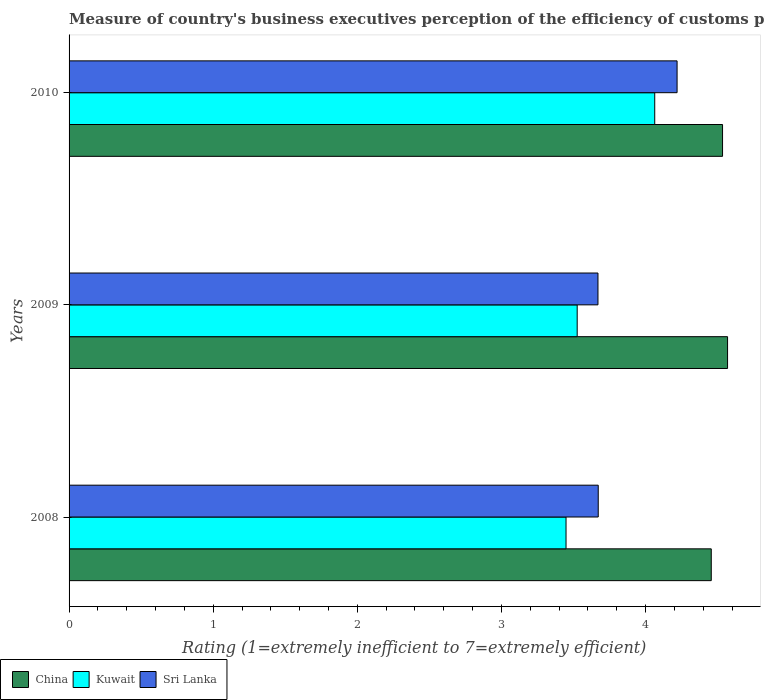How many different coloured bars are there?
Offer a terse response. 3. Are the number of bars on each tick of the Y-axis equal?
Keep it short and to the point. Yes. How many bars are there on the 1st tick from the top?
Offer a very short reply. 3. How many bars are there on the 2nd tick from the bottom?
Give a very brief answer. 3. What is the label of the 1st group of bars from the top?
Keep it short and to the point. 2010. In how many cases, is the number of bars for a given year not equal to the number of legend labels?
Keep it short and to the point. 0. What is the rating of the efficiency of customs procedure in Kuwait in 2009?
Offer a very short reply. 3.53. Across all years, what is the maximum rating of the efficiency of customs procedure in Kuwait?
Ensure brevity in your answer.  4.06. Across all years, what is the minimum rating of the efficiency of customs procedure in China?
Make the answer very short. 4.46. In which year was the rating of the efficiency of customs procedure in Kuwait maximum?
Give a very brief answer. 2010. In which year was the rating of the efficiency of customs procedure in China minimum?
Offer a terse response. 2008. What is the total rating of the efficiency of customs procedure in Kuwait in the graph?
Provide a short and direct response. 11.04. What is the difference between the rating of the efficiency of customs procedure in Sri Lanka in 2008 and that in 2010?
Provide a succinct answer. -0.55. What is the difference between the rating of the efficiency of customs procedure in Sri Lanka in 2010 and the rating of the efficiency of customs procedure in Kuwait in 2008?
Provide a short and direct response. 0.77. What is the average rating of the efficiency of customs procedure in Sri Lanka per year?
Provide a short and direct response. 3.85. In the year 2008, what is the difference between the rating of the efficiency of customs procedure in Kuwait and rating of the efficiency of customs procedure in Sri Lanka?
Your response must be concise. -0.22. What is the ratio of the rating of the efficiency of customs procedure in Sri Lanka in 2008 to that in 2010?
Your answer should be very brief. 0.87. Is the rating of the efficiency of customs procedure in Kuwait in 2008 less than that in 2010?
Your answer should be compact. Yes. What is the difference between the highest and the second highest rating of the efficiency of customs procedure in China?
Provide a short and direct response. 0.03. What is the difference between the highest and the lowest rating of the efficiency of customs procedure in Kuwait?
Give a very brief answer. 0.62. In how many years, is the rating of the efficiency of customs procedure in Sri Lanka greater than the average rating of the efficiency of customs procedure in Sri Lanka taken over all years?
Offer a terse response. 1. Is the sum of the rating of the efficiency of customs procedure in China in 2008 and 2010 greater than the maximum rating of the efficiency of customs procedure in Sri Lanka across all years?
Provide a short and direct response. Yes. What does the 1st bar from the top in 2010 represents?
Provide a succinct answer. Sri Lanka. What does the 2nd bar from the bottom in 2008 represents?
Make the answer very short. Kuwait. Are all the bars in the graph horizontal?
Provide a succinct answer. Yes. How many years are there in the graph?
Give a very brief answer. 3. What is the difference between two consecutive major ticks on the X-axis?
Offer a terse response. 1. Are the values on the major ticks of X-axis written in scientific E-notation?
Offer a very short reply. No. Does the graph contain any zero values?
Your answer should be compact. No. Does the graph contain grids?
Provide a short and direct response. No. Where does the legend appear in the graph?
Provide a short and direct response. Bottom left. How many legend labels are there?
Make the answer very short. 3. What is the title of the graph?
Your answer should be compact. Measure of country's business executives perception of the efficiency of customs procedures. Does "Uruguay" appear as one of the legend labels in the graph?
Your answer should be compact. No. What is the label or title of the X-axis?
Make the answer very short. Rating (1=extremely inefficient to 7=extremely efficient). What is the label or title of the Y-axis?
Give a very brief answer. Years. What is the Rating (1=extremely inefficient to 7=extremely efficient) of China in 2008?
Make the answer very short. 4.46. What is the Rating (1=extremely inefficient to 7=extremely efficient) of Kuwait in 2008?
Your response must be concise. 3.45. What is the Rating (1=extremely inefficient to 7=extremely efficient) in Sri Lanka in 2008?
Offer a terse response. 3.67. What is the Rating (1=extremely inefficient to 7=extremely efficient) in China in 2009?
Make the answer very short. 4.57. What is the Rating (1=extremely inefficient to 7=extremely efficient) of Kuwait in 2009?
Keep it short and to the point. 3.53. What is the Rating (1=extremely inefficient to 7=extremely efficient) of Sri Lanka in 2009?
Make the answer very short. 3.67. What is the Rating (1=extremely inefficient to 7=extremely efficient) in China in 2010?
Your response must be concise. 4.53. What is the Rating (1=extremely inefficient to 7=extremely efficient) of Kuwait in 2010?
Your answer should be very brief. 4.06. What is the Rating (1=extremely inefficient to 7=extremely efficient) in Sri Lanka in 2010?
Provide a succinct answer. 4.22. Across all years, what is the maximum Rating (1=extremely inefficient to 7=extremely efficient) of China?
Offer a terse response. 4.57. Across all years, what is the maximum Rating (1=extremely inefficient to 7=extremely efficient) of Kuwait?
Keep it short and to the point. 4.06. Across all years, what is the maximum Rating (1=extremely inefficient to 7=extremely efficient) in Sri Lanka?
Provide a succinct answer. 4.22. Across all years, what is the minimum Rating (1=extremely inefficient to 7=extremely efficient) in China?
Your response must be concise. 4.46. Across all years, what is the minimum Rating (1=extremely inefficient to 7=extremely efficient) in Kuwait?
Your answer should be compact. 3.45. Across all years, what is the minimum Rating (1=extremely inefficient to 7=extremely efficient) of Sri Lanka?
Keep it short and to the point. 3.67. What is the total Rating (1=extremely inefficient to 7=extremely efficient) of China in the graph?
Your answer should be very brief. 13.56. What is the total Rating (1=extremely inefficient to 7=extremely efficient) of Kuwait in the graph?
Offer a very short reply. 11.04. What is the total Rating (1=extremely inefficient to 7=extremely efficient) of Sri Lanka in the graph?
Provide a short and direct response. 11.56. What is the difference between the Rating (1=extremely inefficient to 7=extremely efficient) in China in 2008 and that in 2009?
Ensure brevity in your answer.  -0.11. What is the difference between the Rating (1=extremely inefficient to 7=extremely efficient) in Kuwait in 2008 and that in 2009?
Provide a succinct answer. -0.08. What is the difference between the Rating (1=extremely inefficient to 7=extremely efficient) of Sri Lanka in 2008 and that in 2009?
Offer a very short reply. 0. What is the difference between the Rating (1=extremely inefficient to 7=extremely efficient) of China in 2008 and that in 2010?
Give a very brief answer. -0.08. What is the difference between the Rating (1=extremely inefficient to 7=extremely efficient) in Kuwait in 2008 and that in 2010?
Ensure brevity in your answer.  -0.62. What is the difference between the Rating (1=extremely inefficient to 7=extremely efficient) of Sri Lanka in 2008 and that in 2010?
Offer a terse response. -0.55. What is the difference between the Rating (1=extremely inefficient to 7=extremely efficient) of China in 2009 and that in 2010?
Offer a very short reply. 0.03. What is the difference between the Rating (1=extremely inefficient to 7=extremely efficient) in Kuwait in 2009 and that in 2010?
Your response must be concise. -0.54. What is the difference between the Rating (1=extremely inefficient to 7=extremely efficient) in Sri Lanka in 2009 and that in 2010?
Your response must be concise. -0.55. What is the difference between the Rating (1=extremely inefficient to 7=extremely efficient) of China in 2008 and the Rating (1=extremely inefficient to 7=extremely efficient) of Kuwait in 2009?
Your response must be concise. 0.93. What is the difference between the Rating (1=extremely inefficient to 7=extremely efficient) of China in 2008 and the Rating (1=extremely inefficient to 7=extremely efficient) of Sri Lanka in 2009?
Offer a terse response. 0.79. What is the difference between the Rating (1=extremely inefficient to 7=extremely efficient) in Kuwait in 2008 and the Rating (1=extremely inefficient to 7=extremely efficient) in Sri Lanka in 2009?
Give a very brief answer. -0.22. What is the difference between the Rating (1=extremely inefficient to 7=extremely efficient) in China in 2008 and the Rating (1=extremely inefficient to 7=extremely efficient) in Kuwait in 2010?
Keep it short and to the point. 0.39. What is the difference between the Rating (1=extremely inefficient to 7=extremely efficient) in China in 2008 and the Rating (1=extremely inefficient to 7=extremely efficient) in Sri Lanka in 2010?
Make the answer very short. 0.24. What is the difference between the Rating (1=extremely inefficient to 7=extremely efficient) in Kuwait in 2008 and the Rating (1=extremely inefficient to 7=extremely efficient) in Sri Lanka in 2010?
Offer a terse response. -0.77. What is the difference between the Rating (1=extremely inefficient to 7=extremely efficient) of China in 2009 and the Rating (1=extremely inefficient to 7=extremely efficient) of Kuwait in 2010?
Give a very brief answer. 0.51. What is the difference between the Rating (1=extremely inefficient to 7=extremely efficient) of China in 2009 and the Rating (1=extremely inefficient to 7=extremely efficient) of Sri Lanka in 2010?
Provide a short and direct response. 0.35. What is the difference between the Rating (1=extremely inefficient to 7=extremely efficient) in Kuwait in 2009 and the Rating (1=extremely inefficient to 7=extremely efficient) in Sri Lanka in 2010?
Keep it short and to the point. -0.69. What is the average Rating (1=extremely inefficient to 7=extremely efficient) of China per year?
Your response must be concise. 4.52. What is the average Rating (1=extremely inefficient to 7=extremely efficient) in Kuwait per year?
Give a very brief answer. 3.68. What is the average Rating (1=extremely inefficient to 7=extremely efficient) of Sri Lanka per year?
Ensure brevity in your answer.  3.85. In the year 2008, what is the difference between the Rating (1=extremely inefficient to 7=extremely efficient) of China and Rating (1=extremely inefficient to 7=extremely efficient) of Kuwait?
Provide a succinct answer. 1.01. In the year 2008, what is the difference between the Rating (1=extremely inefficient to 7=extremely efficient) in China and Rating (1=extremely inefficient to 7=extremely efficient) in Sri Lanka?
Keep it short and to the point. 0.78. In the year 2008, what is the difference between the Rating (1=extremely inefficient to 7=extremely efficient) in Kuwait and Rating (1=extremely inefficient to 7=extremely efficient) in Sri Lanka?
Your answer should be compact. -0.22. In the year 2009, what is the difference between the Rating (1=extremely inefficient to 7=extremely efficient) in China and Rating (1=extremely inefficient to 7=extremely efficient) in Kuwait?
Your answer should be compact. 1.04. In the year 2009, what is the difference between the Rating (1=extremely inefficient to 7=extremely efficient) of China and Rating (1=extremely inefficient to 7=extremely efficient) of Sri Lanka?
Ensure brevity in your answer.  0.9. In the year 2009, what is the difference between the Rating (1=extremely inefficient to 7=extremely efficient) of Kuwait and Rating (1=extremely inefficient to 7=extremely efficient) of Sri Lanka?
Make the answer very short. -0.14. In the year 2010, what is the difference between the Rating (1=extremely inefficient to 7=extremely efficient) in China and Rating (1=extremely inefficient to 7=extremely efficient) in Kuwait?
Ensure brevity in your answer.  0.47. In the year 2010, what is the difference between the Rating (1=extremely inefficient to 7=extremely efficient) of China and Rating (1=extremely inefficient to 7=extremely efficient) of Sri Lanka?
Give a very brief answer. 0.32. In the year 2010, what is the difference between the Rating (1=extremely inefficient to 7=extremely efficient) in Kuwait and Rating (1=extremely inefficient to 7=extremely efficient) in Sri Lanka?
Offer a very short reply. -0.16. What is the ratio of the Rating (1=extremely inefficient to 7=extremely efficient) of China in 2008 to that in 2009?
Provide a short and direct response. 0.98. What is the ratio of the Rating (1=extremely inefficient to 7=extremely efficient) of Kuwait in 2008 to that in 2009?
Your answer should be very brief. 0.98. What is the ratio of the Rating (1=extremely inefficient to 7=extremely efficient) of Sri Lanka in 2008 to that in 2009?
Your response must be concise. 1. What is the ratio of the Rating (1=extremely inefficient to 7=extremely efficient) in China in 2008 to that in 2010?
Ensure brevity in your answer.  0.98. What is the ratio of the Rating (1=extremely inefficient to 7=extremely efficient) in Kuwait in 2008 to that in 2010?
Your response must be concise. 0.85. What is the ratio of the Rating (1=extremely inefficient to 7=extremely efficient) of Sri Lanka in 2008 to that in 2010?
Provide a short and direct response. 0.87. What is the ratio of the Rating (1=extremely inefficient to 7=extremely efficient) in China in 2009 to that in 2010?
Keep it short and to the point. 1.01. What is the ratio of the Rating (1=extremely inefficient to 7=extremely efficient) in Kuwait in 2009 to that in 2010?
Give a very brief answer. 0.87. What is the ratio of the Rating (1=extremely inefficient to 7=extremely efficient) in Sri Lanka in 2009 to that in 2010?
Provide a succinct answer. 0.87. What is the difference between the highest and the second highest Rating (1=extremely inefficient to 7=extremely efficient) of China?
Ensure brevity in your answer.  0.03. What is the difference between the highest and the second highest Rating (1=extremely inefficient to 7=extremely efficient) of Kuwait?
Your answer should be compact. 0.54. What is the difference between the highest and the second highest Rating (1=extremely inefficient to 7=extremely efficient) in Sri Lanka?
Give a very brief answer. 0.55. What is the difference between the highest and the lowest Rating (1=extremely inefficient to 7=extremely efficient) in China?
Offer a very short reply. 0.11. What is the difference between the highest and the lowest Rating (1=extremely inefficient to 7=extremely efficient) in Kuwait?
Ensure brevity in your answer.  0.62. What is the difference between the highest and the lowest Rating (1=extremely inefficient to 7=extremely efficient) in Sri Lanka?
Provide a succinct answer. 0.55. 